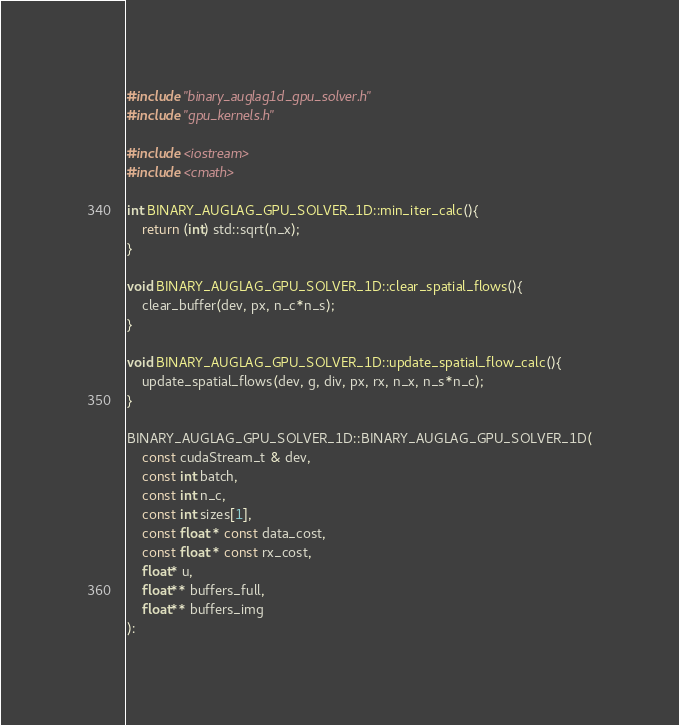<code> <loc_0><loc_0><loc_500><loc_500><_C++_>
#include "binary_auglag1d_gpu_solver.h"
#include "gpu_kernels.h"

#include <iostream>
#include <cmath>

int BINARY_AUGLAG_GPU_SOLVER_1D::min_iter_calc(){
	return (int) std::sqrt(n_x);
}

void BINARY_AUGLAG_GPU_SOLVER_1D::clear_spatial_flows(){
	clear_buffer(dev, px, n_c*n_s);
}

void BINARY_AUGLAG_GPU_SOLVER_1D::update_spatial_flow_calc(){
	update_spatial_flows(dev, g, div, px, rx, n_x, n_s*n_c);
}

BINARY_AUGLAG_GPU_SOLVER_1D::BINARY_AUGLAG_GPU_SOLVER_1D(
	const cudaStream_t & dev,
	const int batch,
    const int n_c,
	const int sizes[1],
	const float * const data_cost,
	const float * const rx_cost,
	float* u,
	float** buffers_full,
	float** buffers_img
):</code> 